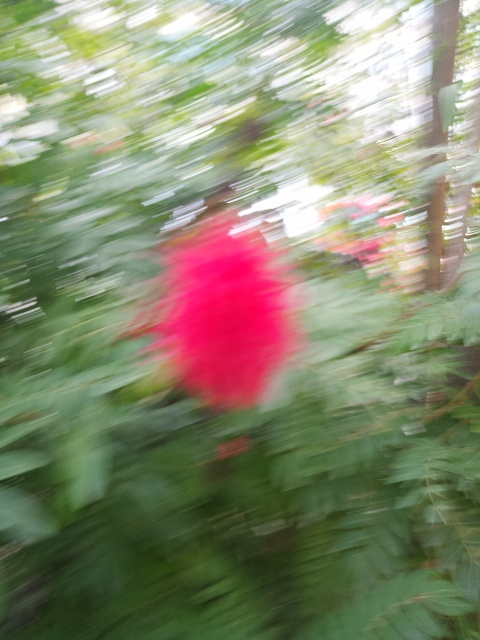What might be the reason for the blurriness in this image? The blurriness in the image could be due to a number of factors, such as motion blur from camera movement or the subject moving, incorrect focus, or it might be intentional to create an artistic effect. The intense blur suggests the camera or subject moved quite a bit during the shot. 